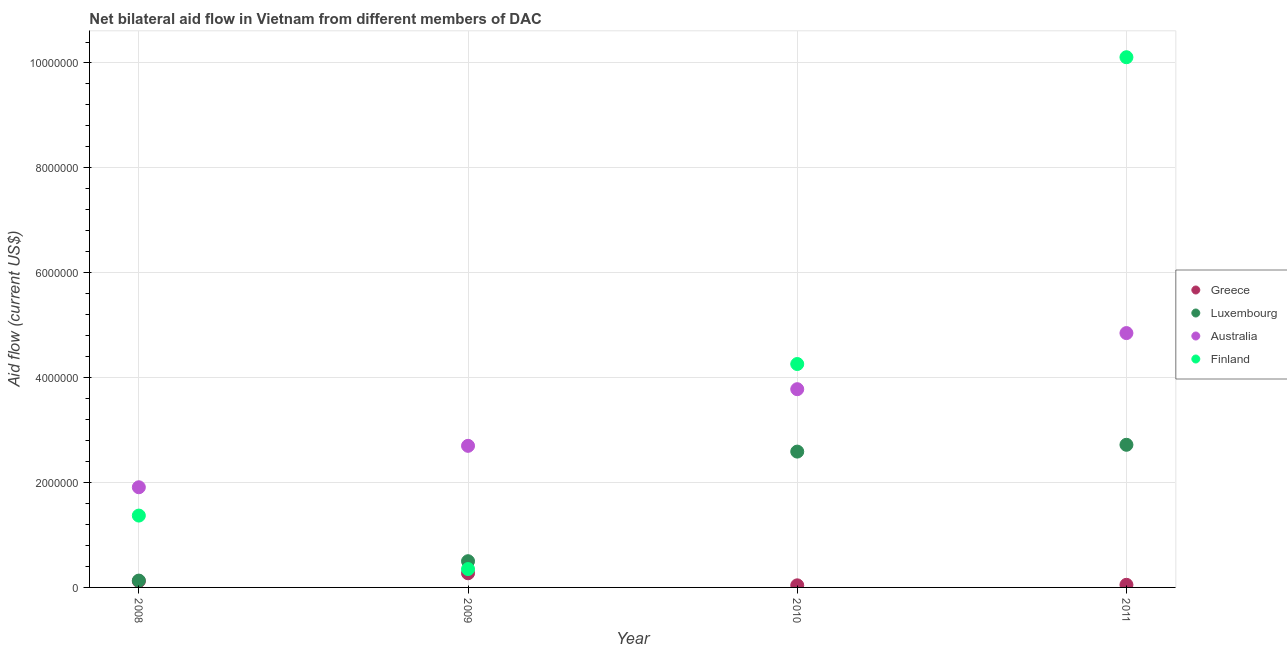How many different coloured dotlines are there?
Offer a very short reply. 4. What is the amount of aid given by greece in 2009?
Offer a terse response. 2.70e+05. Across all years, what is the maximum amount of aid given by finland?
Provide a short and direct response. 1.01e+07. Across all years, what is the minimum amount of aid given by finland?
Offer a very short reply. 3.50e+05. In which year was the amount of aid given by greece maximum?
Your answer should be compact. 2009. In which year was the amount of aid given by finland minimum?
Offer a very short reply. 2009. What is the total amount of aid given by greece in the graph?
Make the answer very short. 4.80e+05. What is the difference between the amount of aid given by australia in 2008 and that in 2010?
Provide a succinct answer. -1.87e+06. What is the difference between the amount of aid given by luxembourg in 2009 and the amount of aid given by australia in 2008?
Your answer should be compact. -1.41e+06. What is the average amount of aid given by finland per year?
Provide a succinct answer. 4.02e+06. In the year 2011, what is the difference between the amount of aid given by finland and amount of aid given by australia?
Provide a short and direct response. 5.26e+06. What is the ratio of the amount of aid given by greece in 2009 to that in 2011?
Your response must be concise. 5.4. What is the difference between the highest and the second highest amount of aid given by luxembourg?
Your response must be concise. 1.30e+05. What is the difference between the highest and the lowest amount of aid given by finland?
Make the answer very short. 9.76e+06. Is the sum of the amount of aid given by greece in 2008 and 2009 greater than the maximum amount of aid given by australia across all years?
Give a very brief answer. No. Is the amount of aid given by greece strictly greater than the amount of aid given by luxembourg over the years?
Give a very brief answer. No. Is the amount of aid given by luxembourg strictly less than the amount of aid given by australia over the years?
Ensure brevity in your answer.  Yes. How many years are there in the graph?
Your response must be concise. 4. Does the graph contain grids?
Ensure brevity in your answer.  Yes. How many legend labels are there?
Make the answer very short. 4. What is the title of the graph?
Your response must be concise. Net bilateral aid flow in Vietnam from different members of DAC. Does "Grants and Revenue" appear as one of the legend labels in the graph?
Give a very brief answer. No. What is the label or title of the Y-axis?
Keep it short and to the point. Aid flow (current US$). What is the Aid flow (current US$) of Australia in 2008?
Offer a terse response. 1.91e+06. What is the Aid flow (current US$) in Finland in 2008?
Give a very brief answer. 1.37e+06. What is the Aid flow (current US$) of Australia in 2009?
Give a very brief answer. 2.70e+06. What is the Aid flow (current US$) in Finland in 2009?
Your answer should be very brief. 3.50e+05. What is the Aid flow (current US$) in Luxembourg in 2010?
Offer a terse response. 2.59e+06. What is the Aid flow (current US$) in Australia in 2010?
Make the answer very short. 3.78e+06. What is the Aid flow (current US$) of Finland in 2010?
Give a very brief answer. 4.26e+06. What is the Aid flow (current US$) of Luxembourg in 2011?
Give a very brief answer. 2.72e+06. What is the Aid flow (current US$) in Australia in 2011?
Give a very brief answer. 4.85e+06. What is the Aid flow (current US$) of Finland in 2011?
Your response must be concise. 1.01e+07. Across all years, what is the maximum Aid flow (current US$) of Luxembourg?
Your answer should be very brief. 2.72e+06. Across all years, what is the maximum Aid flow (current US$) of Australia?
Make the answer very short. 4.85e+06. Across all years, what is the maximum Aid flow (current US$) in Finland?
Make the answer very short. 1.01e+07. Across all years, what is the minimum Aid flow (current US$) of Greece?
Offer a very short reply. 4.00e+04. Across all years, what is the minimum Aid flow (current US$) in Australia?
Give a very brief answer. 1.91e+06. Across all years, what is the minimum Aid flow (current US$) in Finland?
Ensure brevity in your answer.  3.50e+05. What is the total Aid flow (current US$) in Luxembourg in the graph?
Give a very brief answer. 5.94e+06. What is the total Aid flow (current US$) in Australia in the graph?
Your answer should be very brief. 1.32e+07. What is the total Aid flow (current US$) of Finland in the graph?
Provide a short and direct response. 1.61e+07. What is the difference between the Aid flow (current US$) in Luxembourg in 2008 and that in 2009?
Provide a succinct answer. -3.70e+05. What is the difference between the Aid flow (current US$) in Australia in 2008 and that in 2009?
Make the answer very short. -7.90e+05. What is the difference between the Aid flow (current US$) of Finland in 2008 and that in 2009?
Make the answer very short. 1.02e+06. What is the difference between the Aid flow (current US$) of Luxembourg in 2008 and that in 2010?
Keep it short and to the point. -2.46e+06. What is the difference between the Aid flow (current US$) in Australia in 2008 and that in 2010?
Provide a succinct answer. -1.87e+06. What is the difference between the Aid flow (current US$) of Finland in 2008 and that in 2010?
Provide a succinct answer. -2.89e+06. What is the difference between the Aid flow (current US$) in Greece in 2008 and that in 2011?
Offer a very short reply. 7.00e+04. What is the difference between the Aid flow (current US$) of Luxembourg in 2008 and that in 2011?
Provide a succinct answer. -2.59e+06. What is the difference between the Aid flow (current US$) in Australia in 2008 and that in 2011?
Your answer should be compact. -2.94e+06. What is the difference between the Aid flow (current US$) of Finland in 2008 and that in 2011?
Give a very brief answer. -8.74e+06. What is the difference between the Aid flow (current US$) in Luxembourg in 2009 and that in 2010?
Your answer should be very brief. -2.09e+06. What is the difference between the Aid flow (current US$) in Australia in 2009 and that in 2010?
Provide a succinct answer. -1.08e+06. What is the difference between the Aid flow (current US$) in Finland in 2009 and that in 2010?
Your answer should be compact. -3.91e+06. What is the difference between the Aid flow (current US$) of Luxembourg in 2009 and that in 2011?
Give a very brief answer. -2.22e+06. What is the difference between the Aid flow (current US$) of Australia in 2009 and that in 2011?
Ensure brevity in your answer.  -2.15e+06. What is the difference between the Aid flow (current US$) of Finland in 2009 and that in 2011?
Make the answer very short. -9.76e+06. What is the difference between the Aid flow (current US$) in Luxembourg in 2010 and that in 2011?
Ensure brevity in your answer.  -1.30e+05. What is the difference between the Aid flow (current US$) in Australia in 2010 and that in 2011?
Offer a very short reply. -1.07e+06. What is the difference between the Aid flow (current US$) in Finland in 2010 and that in 2011?
Give a very brief answer. -5.85e+06. What is the difference between the Aid flow (current US$) in Greece in 2008 and the Aid flow (current US$) in Luxembourg in 2009?
Make the answer very short. -3.80e+05. What is the difference between the Aid flow (current US$) of Greece in 2008 and the Aid flow (current US$) of Australia in 2009?
Provide a short and direct response. -2.58e+06. What is the difference between the Aid flow (current US$) in Greece in 2008 and the Aid flow (current US$) in Finland in 2009?
Make the answer very short. -2.30e+05. What is the difference between the Aid flow (current US$) of Luxembourg in 2008 and the Aid flow (current US$) of Australia in 2009?
Provide a succinct answer. -2.57e+06. What is the difference between the Aid flow (current US$) of Luxembourg in 2008 and the Aid flow (current US$) of Finland in 2009?
Offer a very short reply. -2.20e+05. What is the difference between the Aid flow (current US$) of Australia in 2008 and the Aid flow (current US$) of Finland in 2009?
Keep it short and to the point. 1.56e+06. What is the difference between the Aid flow (current US$) of Greece in 2008 and the Aid flow (current US$) of Luxembourg in 2010?
Your response must be concise. -2.47e+06. What is the difference between the Aid flow (current US$) of Greece in 2008 and the Aid flow (current US$) of Australia in 2010?
Provide a short and direct response. -3.66e+06. What is the difference between the Aid flow (current US$) of Greece in 2008 and the Aid flow (current US$) of Finland in 2010?
Give a very brief answer. -4.14e+06. What is the difference between the Aid flow (current US$) of Luxembourg in 2008 and the Aid flow (current US$) of Australia in 2010?
Keep it short and to the point. -3.65e+06. What is the difference between the Aid flow (current US$) in Luxembourg in 2008 and the Aid flow (current US$) in Finland in 2010?
Keep it short and to the point. -4.13e+06. What is the difference between the Aid flow (current US$) of Australia in 2008 and the Aid flow (current US$) of Finland in 2010?
Provide a succinct answer. -2.35e+06. What is the difference between the Aid flow (current US$) of Greece in 2008 and the Aid flow (current US$) of Luxembourg in 2011?
Offer a terse response. -2.60e+06. What is the difference between the Aid flow (current US$) of Greece in 2008 and the Aid flow (current US$) of Australia in 2011?
Make the answer very short. -4.73e+06. What is the difference between the Aid flow (current US$) in Greece in 2008 and the Aid flow (current US$) in Finland in 2011?
Your answer should be very brief. -9.99e+06. What is the difference between the Aid flow (current US$) of Luxembourg in 2008 and the Aid flow (current US$) of Australia in 2011?
Offer a very short reply. -4.72e+06. What is the difference between the Aid flow (current US$) in Luxembourg in 2008 and the Aid flow (current US$) in Finland in 2011?
Your answer should be compact. -9.98e+06. What is the difference between the Aid flow (current US$) of Australia in 2008 and the Aid flow (current US$) of Finland in 2011?
Ensure brevity in your answer.  -8.20e+06. What is the difference between the Aid flow (current US$) of Greece in 2009 and the Aid flow (current US$) of Luxembourg in 2010?
Make the answer very short. -2.32e+06. What is the difference between the Aid flow (current US$) in Greece in 2009 and the Aid flow (current US$) in Australia in 2010?
Provide a succinct answer. -3.51e+06. What is the difference between the Aid flow (current US$) in Greece in 2009 and the Aid flow (current US$) in Finland in 2010?
Give a very brief answer. -3.99e+06. What is the difference between the Aid flow (current US$) of Luxembourg in 2009 and the Aid flow (current US$) of Australia in 2010?
Provide a short and direct response. -3.28e+06. What is the difference between the Aid flow (current US$) of Luxembourg in 2009 and the Aid flow (current US$) of Finland in 2010?
Keep it short and to the point. -3.76e+06. What is the difference between the Aid flow (current US$) of Australia in 2009 and the Aid flow (current US$) of Finland in 2010?
Provide a short and direct response. -1.56e+06. What is the difference between the Aid flow (current US$) in Greece in 2009 and the Aid flow (current US$) in Luxembourg in 2011?
Provide a short and direct response. -2.45e+06. What is the difference between the Aid flow (current US$) of Greece in 2009 and the Aid flow (current US$) of Australia in 2011?
Your answer should be compact. -4.58e+06. What is the difference between the Aid flow (current US$) of Greece in 2009 and the Aid flow (current US$) of Finland in 2011?
Provide a succinct answer. -9.84e+06. What is the difference between the Aid flow (current US$) in Luxembourg in 2009 and the Aid flow (current US$) in Australia in 2011?
Make the answer very short. -4.35e+06. What is the difference between the Aid flow (current US$) in Luxembourg in 2009 and the Aid flow (current US$) in Finland in 2011?
Offer a very short reply. -9.61e+06. What is the difference between the Aid flow (current US$) of Australia in 2009 and the Aid flow (current US$) of Finland in 2011?
Provide a succinct answer. -7.41e+06. What is the difference between the Aid flow (current US$) in Greece in 2010 and the Aid flow (current US$) in Luxembourg in 2011?
Give a very brief answer. -2.68e+06. What is the difference between the Aid flow (current US$) of Greece in 2010 and the Aid flow (current US$) of Australia in 2011?
Your response must be concise. -4.81e+06. What is the difference between the Aid flow (current US$) of Greece in 2010 and the Aid flow (current US$) of Finland in 2011?
Provide a short and direct response. -1.01e+07. What is the difference between the Aid flow (current US$) of Luxembourg in 2010 and the Aid flow (current US$) of Australia in 2011?
Make the answer very short. -2.26e+06. What is the difference between the Aid flow (current US$) in Luxembourg in 2010 and the Aid flow (current US$) in Finland in 2011?
Keep it short and to the point. -7.52e+06. What is the difference between the Aid flow (current US$) of Australia in 2010 and the Aid flow (current US$) of Finland in 2011?
Your answer should be very brief. -6.33e+06. What is the average Aid flow (current US$) in Luxembourg per year?
Your answer should be compact. 1.48e+06. What is the average Aid flow (current US$) in Australia per year?
Give a very brief answer. 3.31e+06. What is the average Aid flow (current US$) of Finland per year?
Your response must be concise. 4.02e+06. In the year 2008, what is the difference between the Aid flow (current US$) of Greece and Aid flow (current US$) of Australia?
Ensure brevity in your answer.  -1.79e+06. In the year 2008, what is the difference between the Aid flow (current US$) in Greece and Aid flow (current US$) in Finland?
Offer a terse response. -1.25e+06. In the year 2008, what is the difference between the Aid flow (current US$) in Luxembourg and Aid flow (current US$) in Australia?
Make the answer very short. -1.78e+06. In the year 2008, what is the difference between the Aid flow (current US$) in Luxembourg and Aid flow (current US$) in Finland?
Your answer should be compact. -1.24e+06. In the year 2008, what is the difference between the Aid flow (current US$) of Australia and Aid flow (current US$) of Finland?
Ensure brevity in your answer.  5.40e+05. In the year 2009, what is the difference between the Aid flow (current US$) of Greece and Aid flow (current US$) of Luxembourg?
Provide a short and direct response. -2.30e+05. In the year 2009, what is the difference between the Aid flow (current US$) of Greece and Aid flow (current US$) of Australia?
Ensure brevity in your answer.  -2.43e+06. In the year 2009, what is the difference between the Aid flow (current US$) of Greece and Aid flow (current US$) of Finland?
Ensure brevity in your answer.  -8.00e+04. In the year 2009, what is the difference between the Aid flow (current US$) in Luxembourg and Aid flow (current US$) in Australia?
Keep it short and to the point. -2.20e+06. In the year 2009, what is the difference between the Aid flow (current US$) of Luxembourg and Aid flow (current US$) of Finland?
Provide a succinct answer. 1.50e+05. In the year 2009, what is the difference between the Aid flow (current US$) of Australia and Aid flow (current US$) of Finland?
Offer a very short reply. 2.35e+06. In the year 2010, what is the difference between the Aid flow (current US$) of Greece and Aid flow (current US$) of Luxembourg?
Your response must be concise. -2.55e+06. In the year 2010, what is the difference between the Aid flow (current US$) in Greece and Aid flow (current US$) in Australia?
Your response must be concise. -3.74e+06. In the year 2010, what is the difference between the Aid flow (current US$) in Greece and Aid flow (current US$) in Finland?
Your answer should be compact. -4.22e+06. In the year 2010, what is the difference between the Aid flow (current US$) in Luxembourg and Aid flow (current US$) in Australia?
Give a very brief answer. -1.19e+06. In the year 2010, what is the difference between the Aid flow (current US$) in Luxembourg and Aid flow (current US$) in Finland?
Offer a terse response. -1.67e+06. In the year 2010, what is the difference between the Aid flow (current US$) in Australia and Aid flow (current US$) in Finland?
Keep it short and to the point. -4.80e+05. In the year 2011, what is the difference between the Aid flow (current US$) in Greece and Aid flow (current US$) in Luxembourg?
Your answer should be compact. -2.67e+06. In the year 2011, what is the difference between the Aid flow (current US$) in Greece and Aid flow (current US$) in Australia?
Make the answer very short. -4.80e+06. In the year 2011, what is the difference between the Aid flow (current US$) in Greece and Aid flow (current US$) in Finland?
Make the answer very short. -1.01e+07. In the year 2011, what is the difference between the Aid flow (current US$) in Luxembourg and Aid flow (current US$) in Australia?
Your answer should be compact. -2.13e+06. In the year 2011, what is the difference between the Aid flow (current US$) in Luxembourg and Aid flow (current US$) in Finland?
Offer a terse response. -7.39e+06. In the year 2011, what is the difference between the Aid flow (current US$) of Australia and Aid flow (current US$) of Finland?
Give a very brief answer. -5.26e+06. What is the ratio of the Aid flow (current US$) in Greece in 2008 to that in 2009?
Your response must be concise. 0.44. What is the ratio of the Aid flow (current US$) of Luxembourg in 2008 to that in 2009?
Offer a terse response. 0.26. What is the ratio of the Aid flow (current US$) of Australia in 2008 to that in 2009?
Give a very brief answer. 0.71. What is the ratio of the Aid flow (current US$) of Finland in 2008 to that in 2009?
Offer a very short reply. 3.91. What is the ratio of the Aid flow (current US$) in Greece in 2008 to that in 2010?
Ensure brevity in your answer.  3. What is the ratio of the Aid flow (current US$) of Luxembourg in 2008 to that in 2010?
Offer a very short reply. 0.05. What is the ratio of the Aid flow (current US$) in Australia in 2008 to that in 2010?
Ensure brevity in your answer.  0.51. What is the ratio of the Aid flow (current US$) of Finland in 2008 to that in 2010?
Provide a short and direct response. 0.32. What is the ratio of the Aid flow (current US$) of Greece in 2008 to that in 2011?
Provide a succinct answer. 2.4. What is the ratio of the Aid flow (current US$) of Luxembourg in 2008 to that in 2011?
Your answer should be compact. 0.05. What is the ratio of the Aid flow (current US$) in Australia in 2008 to that in 2011?
Offer a very short reply. 0.39. What is the ratio of the Aid flow (current US$) of Finland in 2008 to that in 2011?
Your answer should be very brief. 0.14. What is the ratio of the Aid flow (current US$) of Greece in 2009 to that in 2010?
Provide a short and direct response. 6.75. What is the ratio of the Aid flow (current US$) in Luxembourg in 2009 to that in 2010?
Your answer should be very brief. 0.19. What is the ratio of the Aid flow (current US$) of Australia in 2009 to that in 2010?
Offer a very short reply. 0.71. What is the ratio of the Aid flow (current US$) of Finland in 2009 to that in 2010?
Keep it short and to the point. 0.08. What is the ratio of the Aid flow (current US$) in Greece in 2009 to that in 2011?
Offer a terse response. 5.4. What is the ratio of the Aid flow (current US$) of Luxembourg in 2009 to that in 2011?
Your answer should be compact. 0.18. What is the ratio of the Aid flow (current US$) in Australia in 2009 to that in 2011?
Keep it short and to the point. 0.56. What is the ratio of the Aid flow (current US$) in Finland in 2009 to that in 2011?
Give a very brief answer. 0.03. What is the ratio of the Aid flow (current US$) in Luxembourg in 2010 to that in 2011?
Keep it short and to the point. 0.95. What is the ratio of the Aid flow (current US$) of Australia in 2010 to that in 2011?
Give a very brief answer. 0.78. What is the ratio of the Aid flow (current US$) in Finland in 2010 to that in 2011?
Your answer should be compact. 0.42. What is the difference between the highest and the second highest Aid flow (current US$) in Luxembourg?
Your answer should be very brief. 1.30e+05. What is the difference between the highest and the second highest Aid flow (current US$) in Australia?
Make the answer very short. 1.07e+06. What is the difference between the highest and the second highest Aid flow (current US$) in Finland?
Offer a very short reply. 5.85e+06. What is the difference between the highest and the lowest Aid flow (current US$) of Greece?
Make the answer very short. 2.30e+05. What is the difference between the highest and the lowest Aid flow (current US$) in Luxembourg?
Make the answer very short. 2.59e+06. What is the difference between the highest and the lowest Aid flow (current US$) of Australia?
Make the answer very short. 2.94e+06. What is the difference between the highest and the lowest Aid flow (current US$) of Finland?
Ensure brevity in your answer.  9.76e+06. 